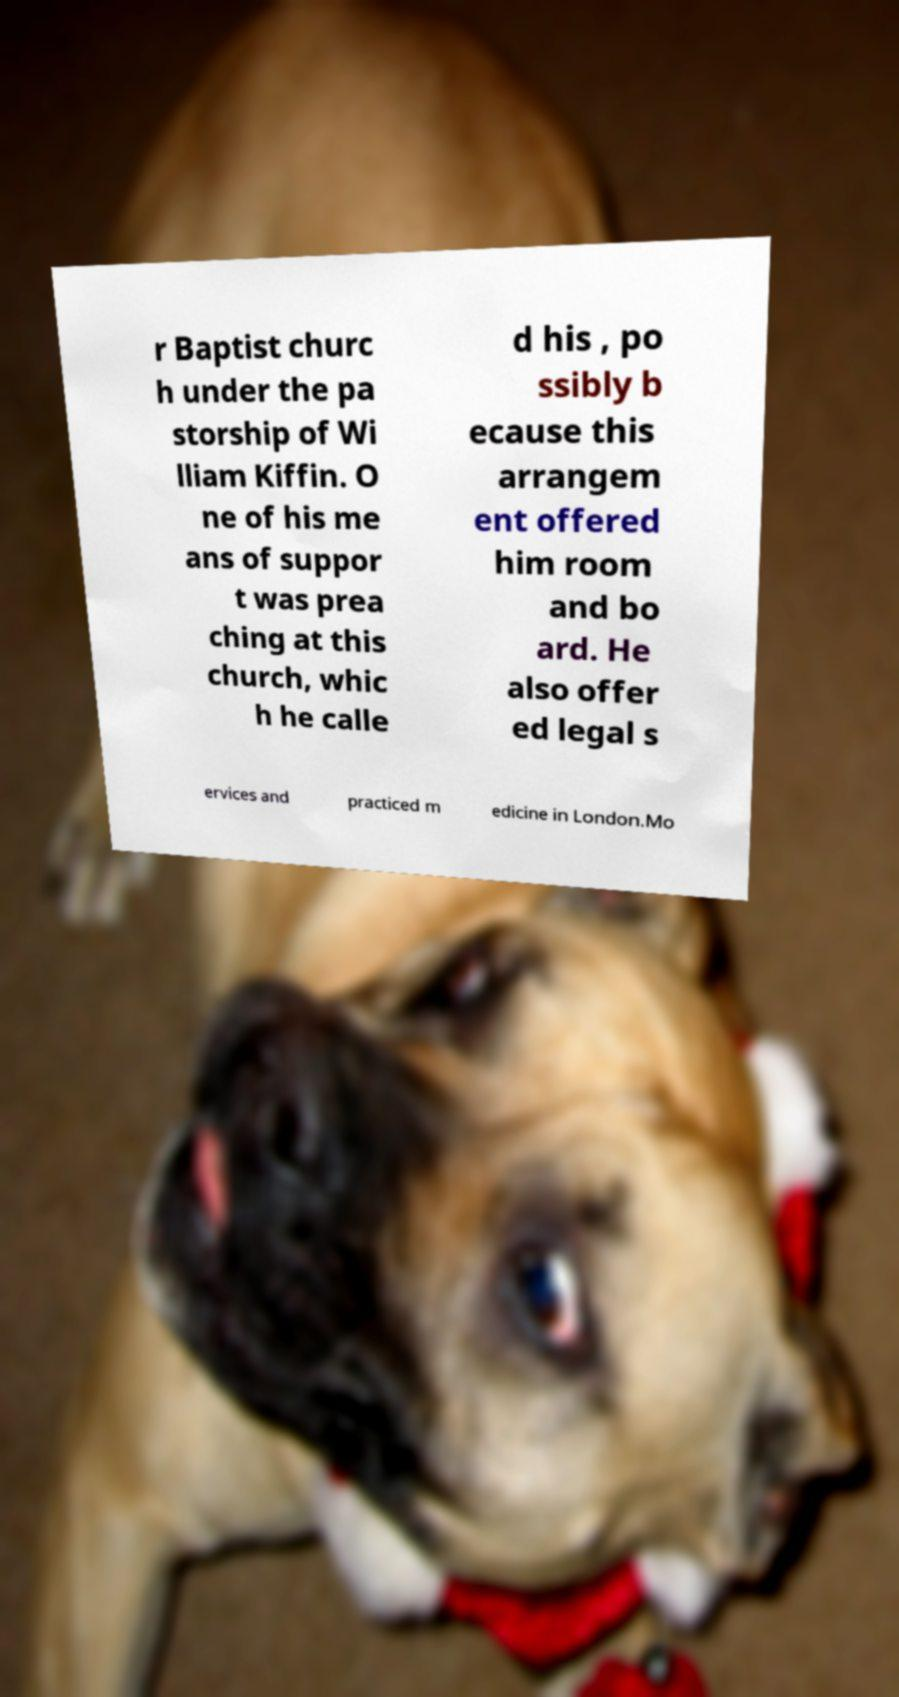Please identify and transcribe the text found in this image. r Baptist churc h under the pa storship of Wi lliam Kiffin. O ne of his me ans of suppor t was prea ching at this church, whic h he calle d his , po ssibly b ecause this arrangem ent offered him room and bo ard. He also offer ed legal s ervices and practiced m edicine in London.Mo 